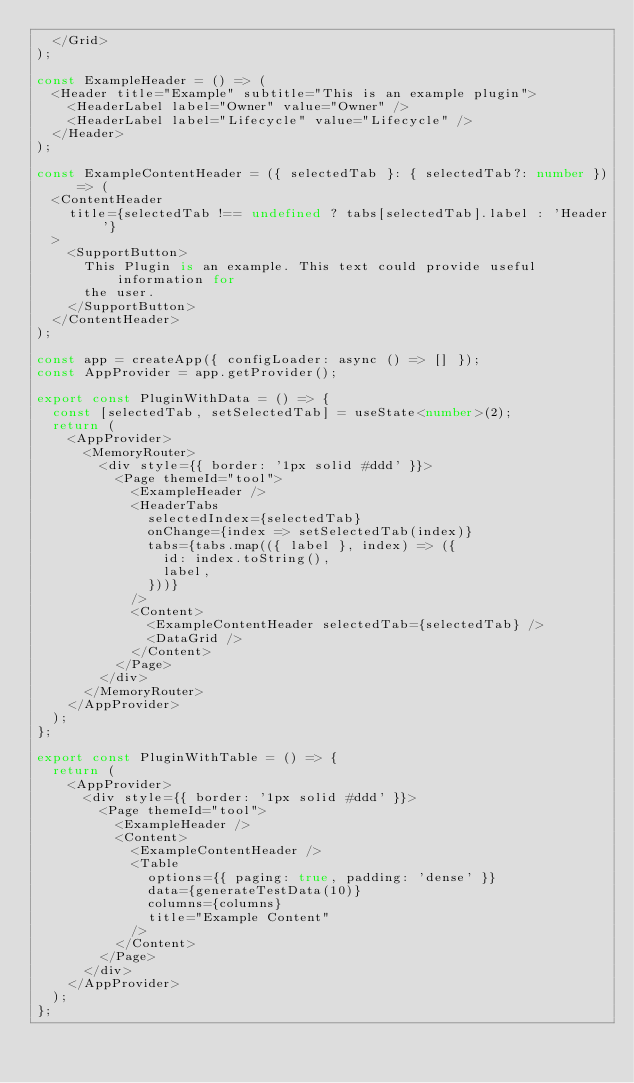Convert code to text. <code><loc_0><loc_0><loc_500><loc_500><_TypeScript_>  </Grid>
);

const ExampleHeader = () => (
  <Header title="Example" subtitle="This is an example plugin">
    <HeaderLabel label="Owner" value="Owner" />
    <HeaderLabel label="Lifecycle" value="Lifecycle" />
  </Header>
);

const ExampleContentHeader = ({ selectedTab }: { selectedTab?: number }) => (
  <ContentHeader
    title={selectedTab !== undefined ? tabs[selectedTab].label : 'Header'}
  >
    <SupportButton>
      This Plugin is an example. This text could provide useful information for
      the user.
    </SupportButton>
  </ContentHeader>
);

const app = createApp({ configLoader: async () => [] });
const AppProvider = app.getProvider();

export const PluginWithData = () => {
  const [selectedTab, setSelectedTab] = useState<number>(2);
  return (
    <AppProvider>
      <MemoryRouter>
        <div style={{ border: '1px solid #ddd' }}>
          <Page themeId="tool">
            <ExampleHeader />
            <HeaderTabs
              selectedIndex={selectedTab}
              onChange={index => setSelectedTab(index)}
              tabs={tabs.map(({ label }, index) => ({
                id: index.toString(),
                label,
              }))}
            />
            <Content>
              <ExampleContentHeader selectedTab={selectedTab} />
              <DataGrid />
            </Content>
          </Page>
        </div>
      </MemoryRouter>
    </AppProvider>
  );
};

export const PluginWithTable = () => {
  return (
    <AppProvider>
      <div style={{ border: '1px solid #ddd' }}>
        <Page themeId="tool">
          <ExampleHeader />
          <Content>
            <ExampleContentHeader />
            <Table
              options={{ paging: true, padding: 'dense' }}
              data={generateTestData(10)}
              columns={columns}
              title="Example Content"
            />
          </Content>
        </Page>
      </div>
    </AppProvider>
  );
};
</code> 